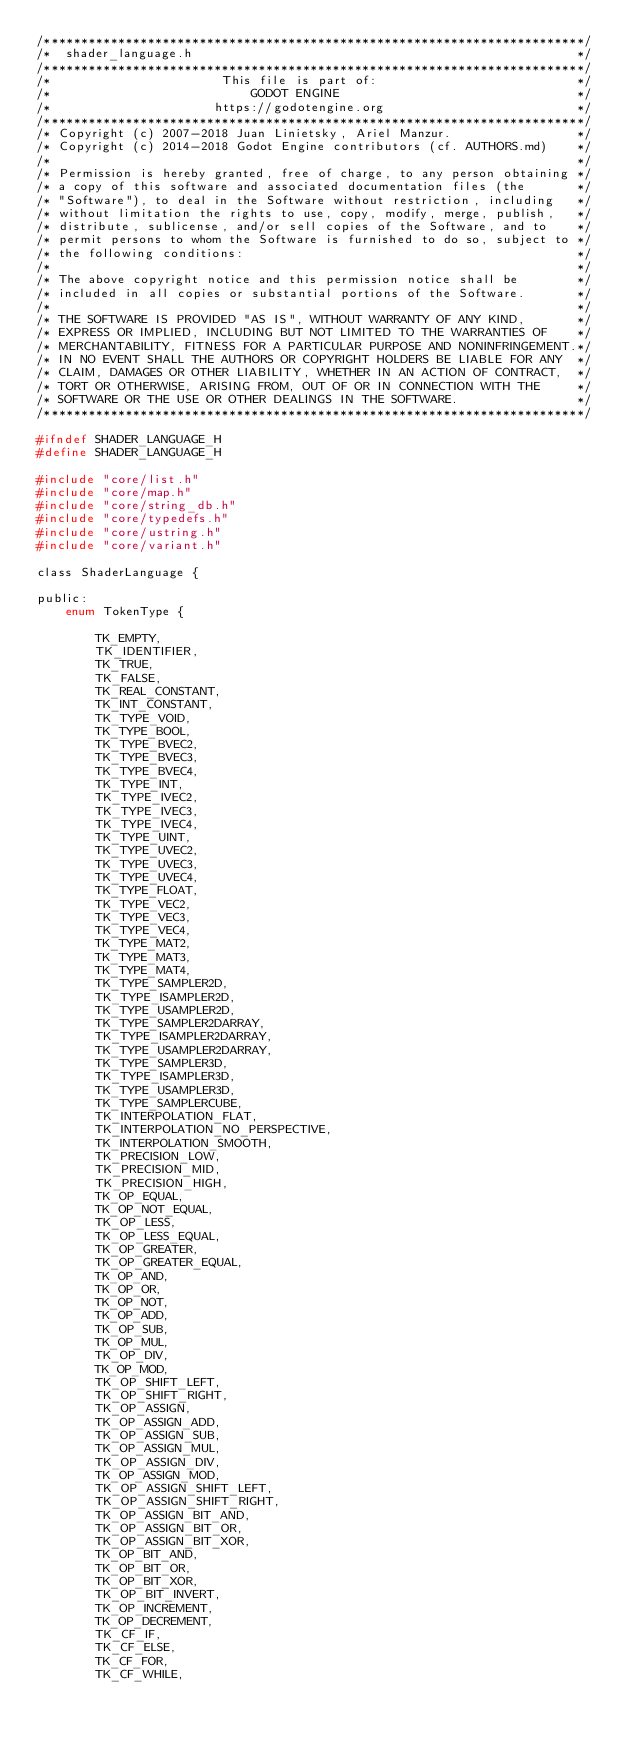Convert code to text. <code><loc_0><loc_0><loc_500><loc_500><_C_>/*************************************************************************/
/*  shader_language.h                                                    */
/*************************************************************************/
/*                       This file is part of:                           */
/*                           GODOT ENGINE                                */
/*                      https://godotengine.org                          */
/*************************************************************************/
/* Copyright (c) 2007-2018 Juan Linietsky, Ariel Manzur.                 */
/* Copyright (c) 2014-2018 Godot Engine contributors (cf. AUTHORS.md)    */
/*                                                                       */
/* Permission is hereby granted, free of charge, to any person obtaining */
/* a copy of this software and associated documentation files (the       */
/* "Software"), to deal in the Software without restriction, including   */
/* without limitation the rights to use, copy, modify, merge, publish,   */
/* distribute, sublicense, and/or sell copies of the Software, and to    */
/* permit persons to whom the Software is furnished to do so, subject to */
/* the following conditions:                                             */
/*                                                                       */
/* The above copyright notice and this permission notice shall be        */
/* included in all copies or substantial portions of the Software.       */
/*                                                                       */
/* THE SOFTWARE IS PROVIDED "AS IS", WITHOUT WARRANTY OF ANY KIND,       */
/* EXPRESS OR IMPLIED, INCLUDING BUT NOT LIMITED TO THE WARRANTIES OF    */
/* MERCHANTABILITY, FITNESS FOR A PARTICULAR PURPOSE AND NONINFRINGEMENT.*/
/* IN NO EVENT SHALL THE AUTHORS OR COPYRIGHT HOLDERS BE LIABLE FOR ANY  */
/* CLAIM, DAMAGES OR OTHER LIABILITY, WHETHER IN AN ACTION OF CONTRACT,  */
/* TORT OR OTHERWISE, ARISING FROM, OUT OF OR IN CONNECTION WITH THE     */
/* SOFTWARE OR THE USE OR OTHER DEALINGS IN THE SOFTWARE.                */
/*************************************************************************/

#ifndef SHADER_LANGUAGE_H
#define SHADER_LANGUAGE_H

#include "core/list.h"
#include "core/map.h"
#include "core/string_db.h"
#include "core/typedefs.h"
#include "core/ustring.h"
#include "core/variant.h"

class ShaderLanguage {

public:
	enum TokenType {

		TK_EMPTY,
		TK_IDENTIFIER,
		TK_TRUE,
		TK_FALSE,
		TK_REAL_CONSTANT,
		TK_INT_CONSTANT,
		TK_TYPE_VOID,
		TK_TYPE_BOOL,
		TK_TYPE_BVEC2,
		TK_TYPE_BVEC3,
		TK_TYPE_BVEC4,
		TK_TYPE_INT,
		TK_TYPE_IVEC2,
		TK_TYPE_IVEC3,
		TK_TYPE_IVEC4,
		TK_TYPE_UINT,
		TK_TYPE_UVEC2,
		TK_TYPE_UVEC3,
		TK_TYPE_UVEC4,
		TK_TYPE_FLOAT,
		TK_TYPE_VEC2,
		TK_TYPE_VEC3,
		TK_TYPE_VEC4,
		TK_TYPE_MAT2,
		TK_TYPE_MAT3,
		TK_TYPE_MAT4,
		TK_TYPE_SAMPLER2D,
		TK_TYPE_ISAMPLER2D,
		TK_TYPE_USAMPLER2D,
		TK_TYPE_SAMPLER2DARRAY,
		TK_TYPE_ISAMPLER2DARRAY,
		TK_TYPE_USAMPLER2DARRAY,
		TK_TYPE_SAMPLER3D,
		TK_TYPE_ISAMPLER3D,
		TK_TYPE_USAMPLER3D,
		TK_TYPE_SAMPLERCUBE,
		TK_INTERPOLATION_FLAT,
		TK_INTERPOLATION_NO_PERSPECTIVE,
		TK_INTERPOLATION_SMOOTH,
		TK_PRECISION_LOW,
		TK_PRECISION_MID,
		TK_PRECISION_HIGH,
		TK_OP_EQUAL,
		TK_OP_NOT_EQUAL,
		TK_OP_LESS,
		TK_OP_LESS_EQUAL,
		TK_OP_GREATER,
		TK_OP_GREATER_EQUAL,
		TK_OP_AND,
		TK_OP_OR,
		TK_OP_NOT,
		TK_OP_ADD,
		TK_OP_SUB,
		TK_OP_MUL,
		TK_OP_DIV,
		TK_OP_MOD,
		TK_OP_SHIFT_LEFT,
		TK_OP_SHIFT_RIGHT,
		TK_OP_ASSIGN,
		TK_OP_ASSIGN_ADD,
		TK_OP_ASSIGN_SUB,
		TK_OP_ASSIGN_MUL,
		TK_OP_ASSIGN_DIV,
		TK_OP_ASSIGN_MOD,
		TK_OP_ASSIGN_SHIFT_LEFT,
		TK_OP_ASSIGN_SHIFT_RIGHT,
		TK_OP_ASSIGN_BIT_AND,
		TK_OP_ASSIGN_BIT_OR,
		TK_OP_ASSIGN_BIT_XOR,
		TK_OP_BIT_AND,
		TK_OP_BIT_OR,
		TK_OP_BIT_XOR,
		TK_OP_BIT_INVERT,
		TK_OP_INCREMENT,
		TK_OP_DECREMENT,
		TK_CF_IF,
		TK_CF_ELSE,
		TK_CF_FOR,
		TK_CF_WHILE,</code> 